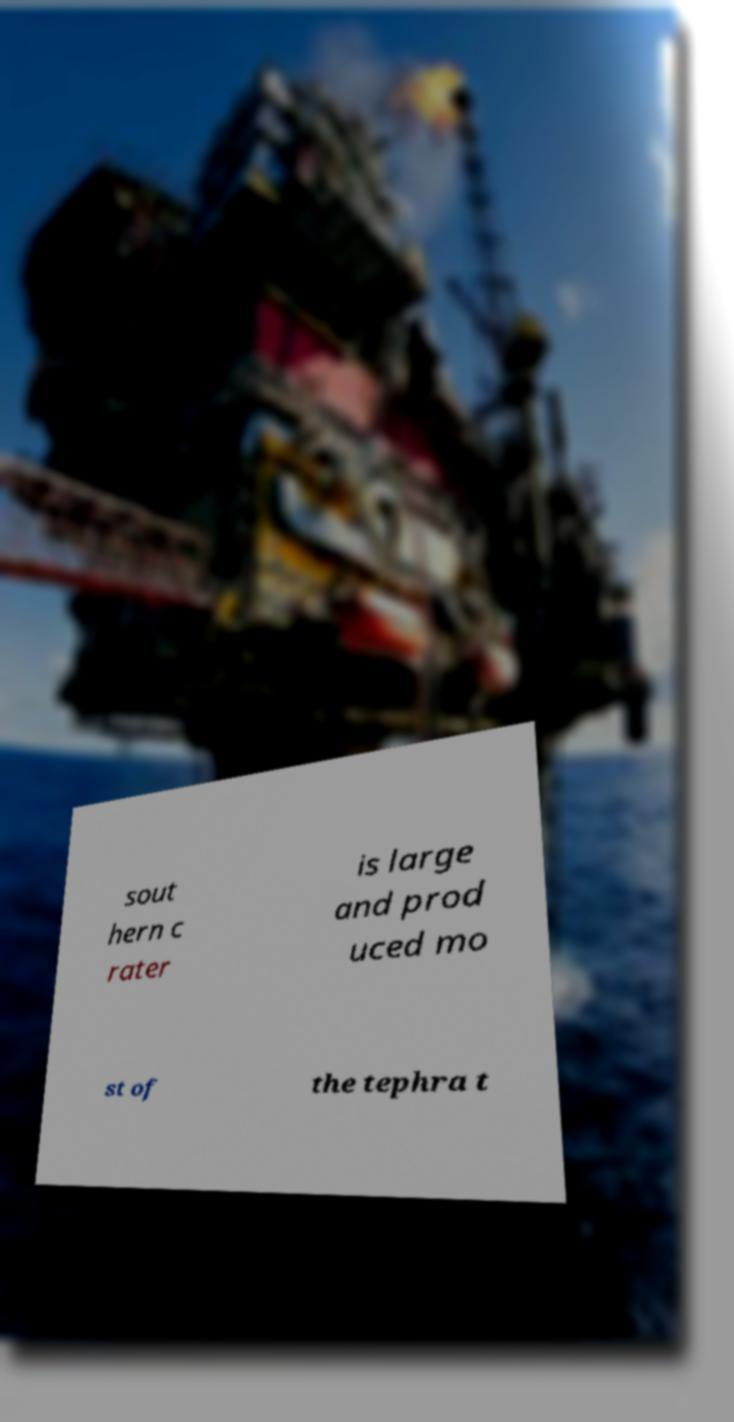For documentation purposes, I need the text within this image transcribed. Could you provide that? sout hern c rater is large and prod uced mo st of the tephra t 